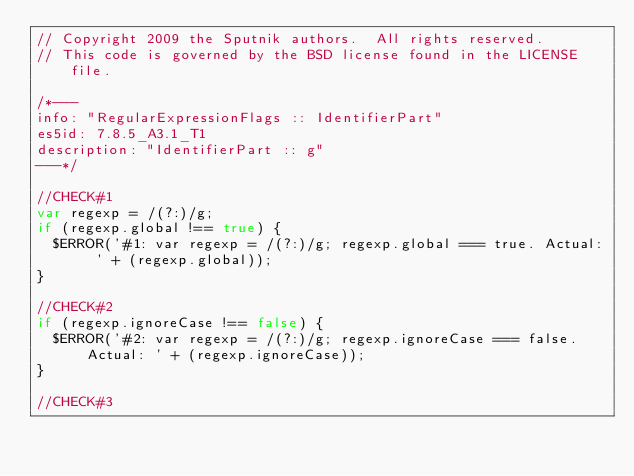Convert code to text. <code><loc_0><loc_0><loc_500><loc_500><_JavaScript_>// Copyright 2009 the Sputnik authors.  All rights reserved.
// This code is governed by the BSD license found in the LICENSE file.

/*---
info: "RegularExpressionFlags :: IdentifierPart"
es5id: 7.8.5_A3.1_T1
description: "IdentifierPart :: g"
---*/

//CHECK#1
var regexp = /(?:)/g; 
if (regexp.global !== true) {
  $ERROR('#1: var regexp = /(?:)/g; regexp.global === true. Actual: ' + (regexp.global));
}

//CHECK#2 
if (regexp.ignoreCase !== false) {
  $ERROR('#2: var regexp = /(?:)/g; regexp.ignoreCase === false. Actual: ' + (regexp.ignoreCase));
}

//CHECK#3</code> 